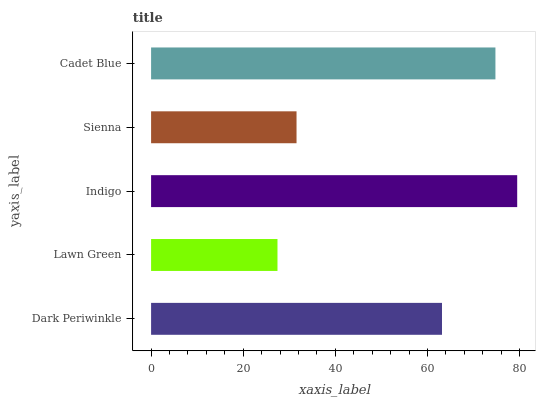Is Lawn Green the minimum?
Answer yes or no. Yes. Is Indigo the maximum?
Answer yes or no. Yes. Is Indigo the minimum?
Answer yes or no. No. Is Lawn Green the maximum?
Answer yes or no. No. Is Indigo greater than Lawn Green?
Answer yes or no. Yes. Is Lawn Green less than Indigo?
Answer yes or no. Yes. Is Lawn Green greater than Indigo?
Answer yes or no. No. Is Indigo less than Lawn Green?
Answer yes or no. No. Is Dark Periwinkle the high median?
Answer yes or no. Yes. Is Dark Periwinkle the low median?
Answer yes or no. Yes. Is Indigo the high median?
Answer yes or no. No. Is Cadet Blue the low median?
Answer yes or no. No. 